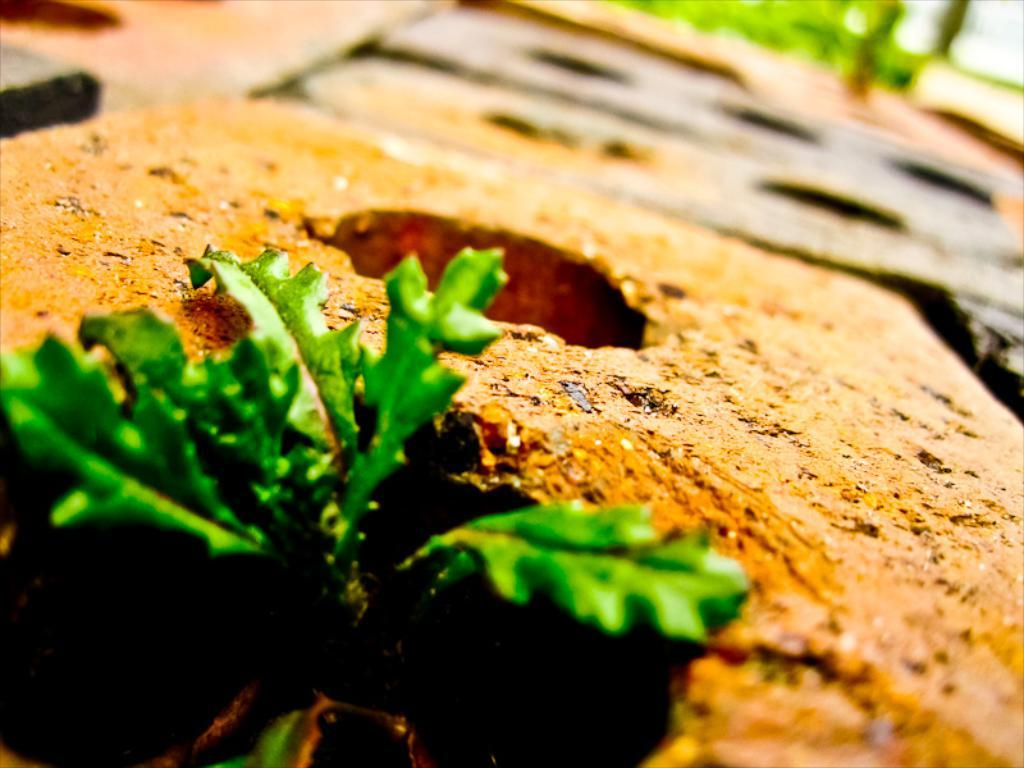What type of living organism can be seen in the image? There is a plant in the image. What is visible beneath the plant in the image? The ground is visible in the image. Can you describe the background of the image? The background of the image is blurred. What type of band can be heard playing in the background of the image? There is no band present in the image, and therefore no sound can be heard. 